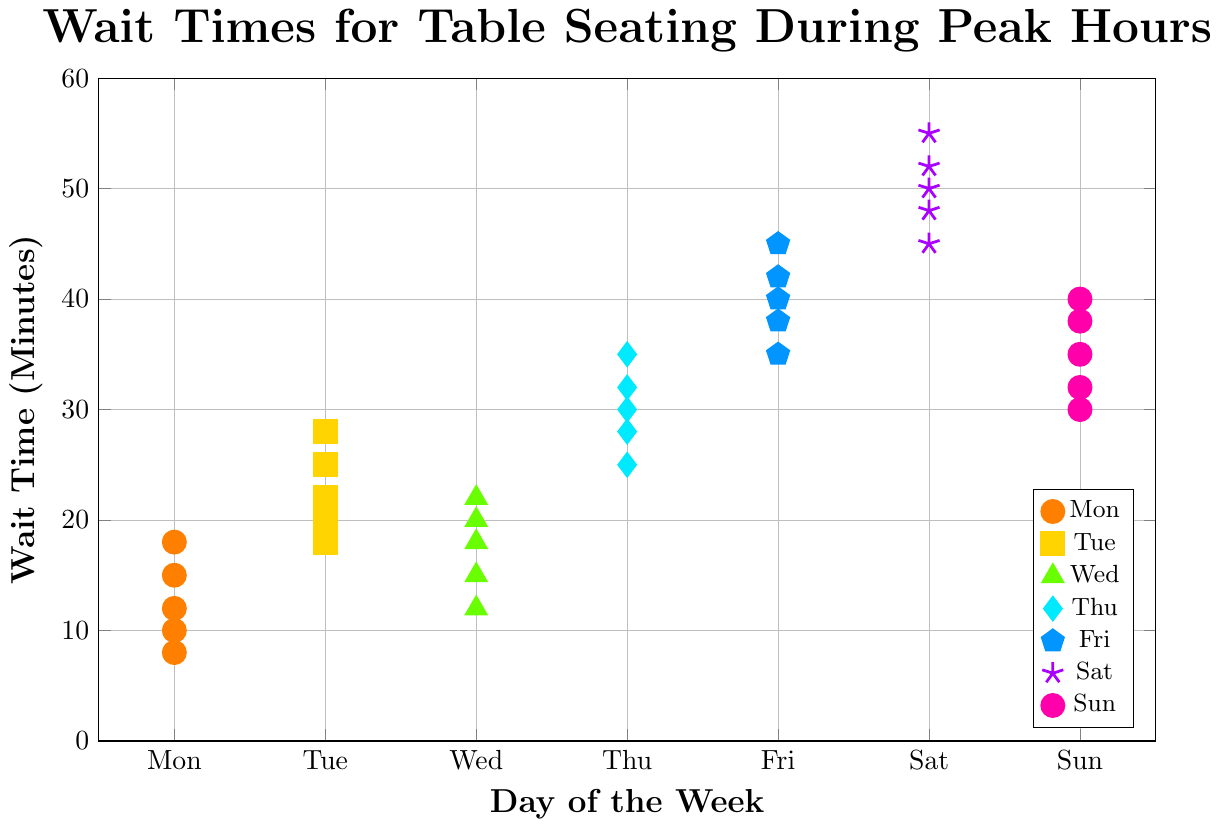Which day has the shortest wait time? The shortest wait time is visually the lowest point on the y-axis. For Monday, the shortest wait time is 8 minutes.
Answer: Monday What is the range of wait times on Friday? The range is found by subtracting the shortest wait time from the longest wait time for Friday. The minimum is 35, and the maximum is 45, so 45 - 35 = 10 minutes.
Answer: 10 minutes How does the average wait time on Tuesday compare to that on Monday? Calculate the average wait time for both days, then compare. Monday: (10+15+12+18+8)/5 = 12.6 minutes. Tuesday: (20+25+22+28+18)/5 = 22.6 minutes. Tuesday's average is higher by 10 minutes.
Answer: Tuesday is higher by 10 minutes Which day has the most consistent wait times? Consistency can be inferred from the spread of the points on each day. Narrow spreads indicate more consistency. By viewing the spread, Wednesday has points close together.
Answer: Wednesday What is the median wait time on Saturday? Arrange Saturday's wait times in order and find the middle value: 45, 48, 50, 52, 55. The middle value (median) is 50.
Answer: 50 minutes Are wait times on Thursday generally longer or shorter than on Sunday? Compare the spread and height of the dots for Thursday and Sunday. Thursday's times are all above Sunday’s, indicating they are generally longer.
Answer: Longer What's the difference between the longest wait time on Wednesday and the shortest on Friday? Longest wait on Wednesday is 22, and the shortest on Friday is 35. So, 35 - 22 = 13 minutes.
Answer: 13 minutes How many days have wait times exceeding 50 minutes? Check each day's highest point to see if it exceeds 50 minutes. Only Saturday exceeds 50 with times up to 55 minutes.
Answer: 1 day What is the average wait time on Thursday? Calculate: (30+35+28+32+25)/5 = 30 minutes.
Answer: 30 minutes 